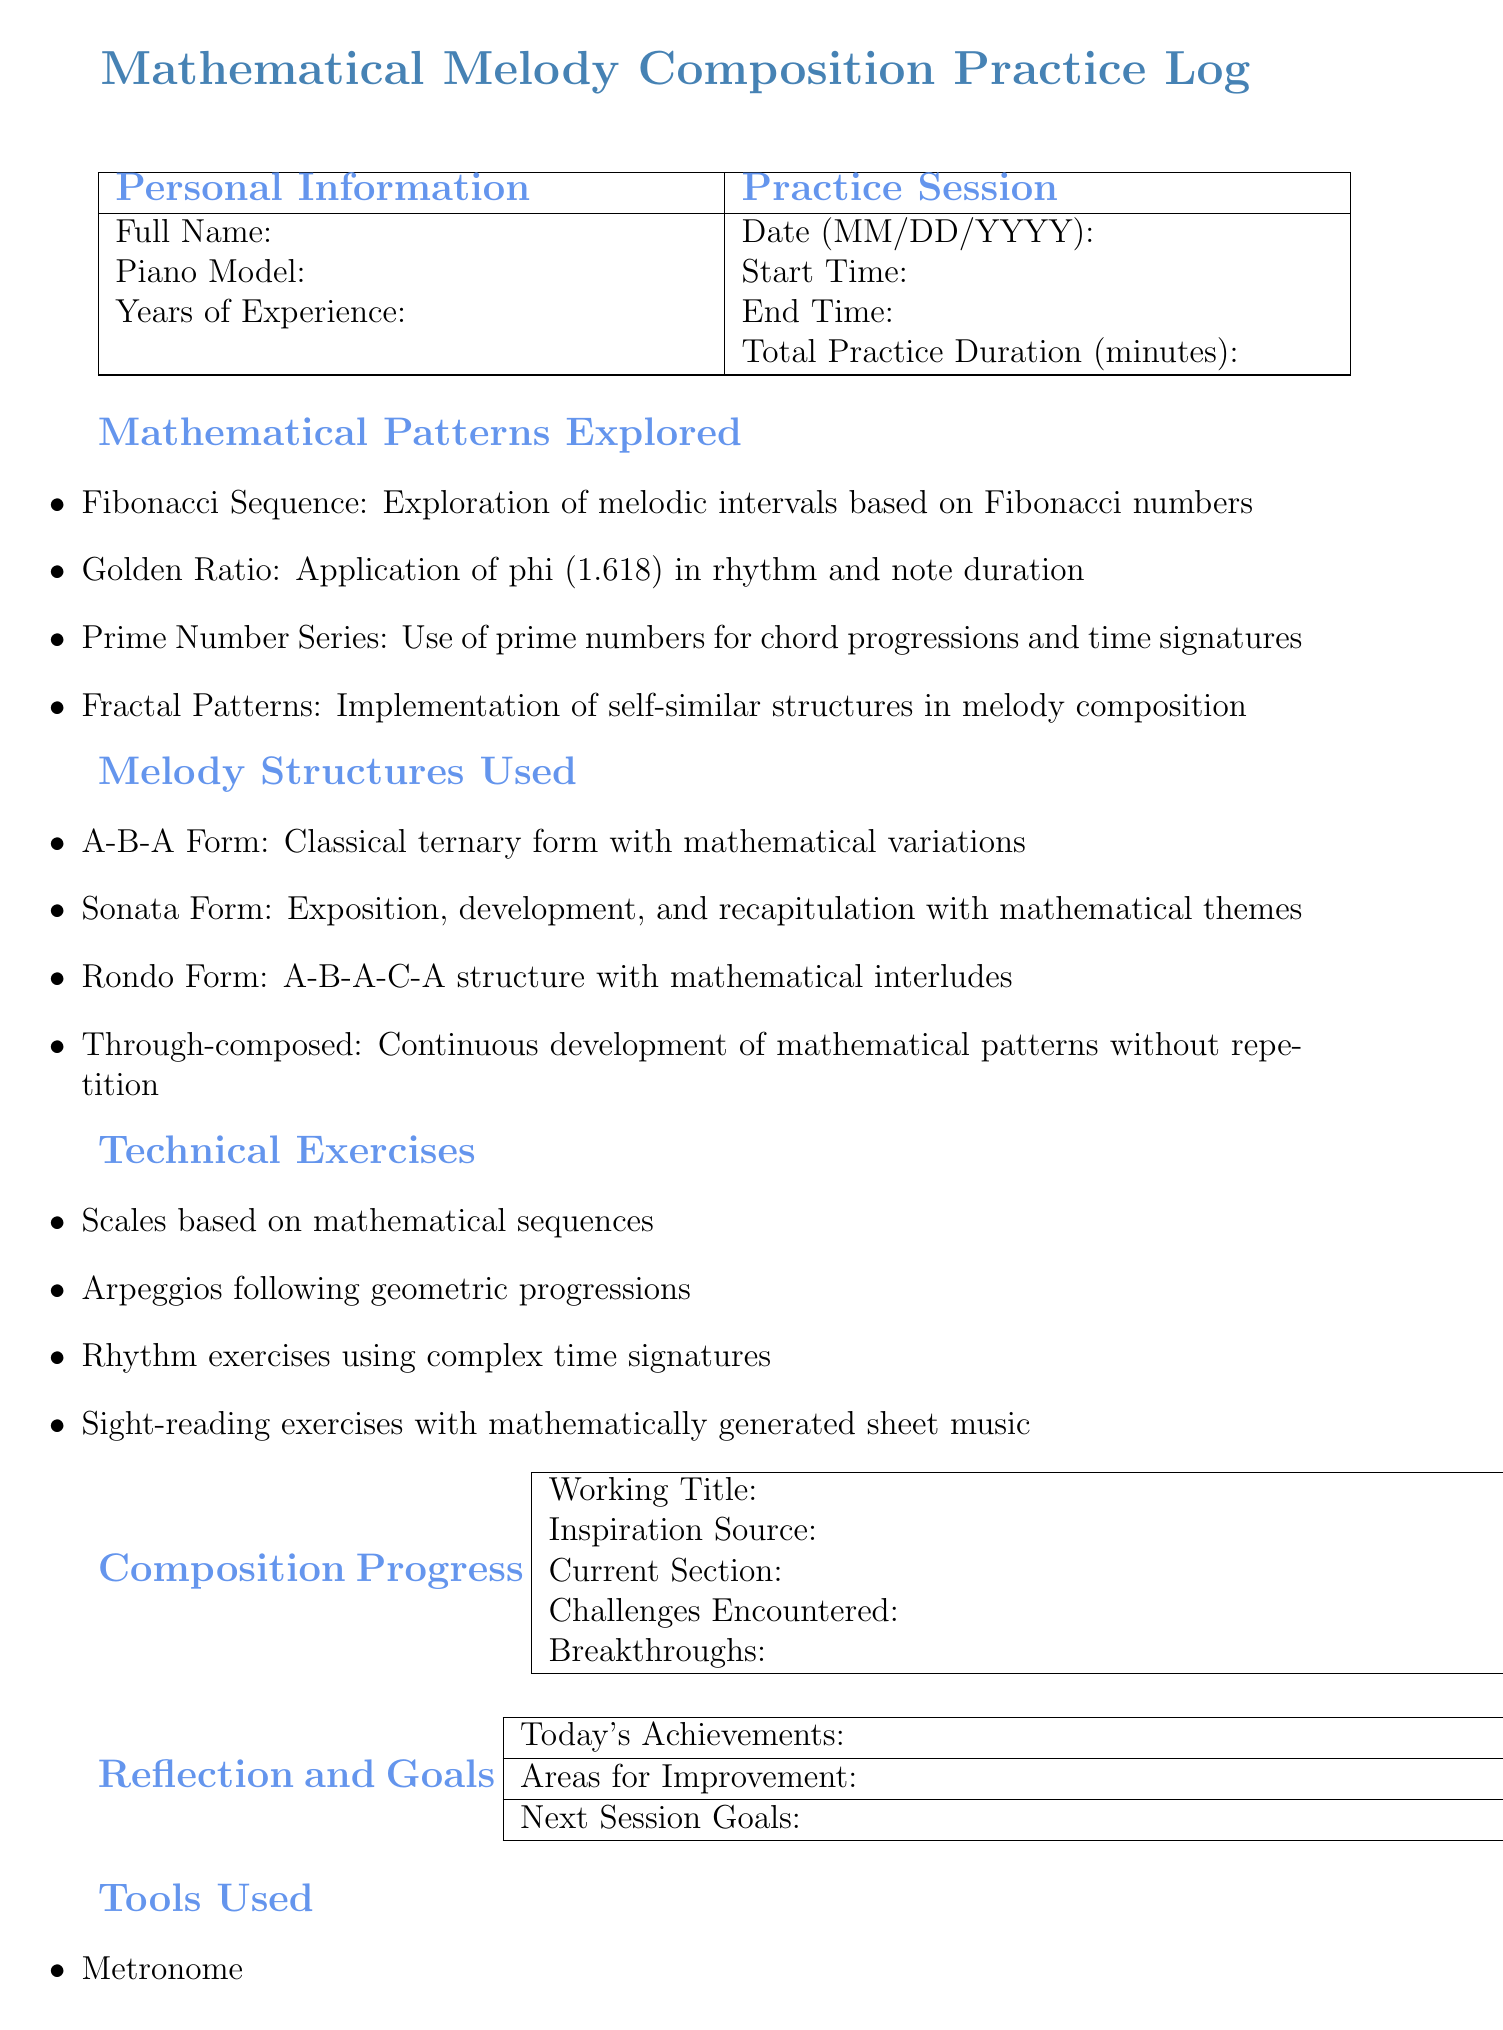What is the title of the document? The title is stated at the top of the document as the main heading.
Answer: Mathematical Melody Composition Practice Log What is the experience level field called? The document includes a section for personal information including a field for experience level.
Answer: Years of Experience What mathematical pattern explores melodic intervals? The document lists various mathematical patterns explored during practice, including one that focuses on melodic intervals.
Answer: Fibonacci Sequence What is the current section of the composition in progress? The composition progress section contains a field to indicate what part of the piece is being worked on.
Answer: Section of the Piece What type of piano is mentioned as an example? The personal information section includes an example of a piano model associated with the practice log.
Answer: Steinway Grand Piano What is indicated under today's achievements? There is a section in the reflection and goals part of the document dedicated to key accomplishments from the practice session.
Answer: Key Accomplishments of the Practice Session What tool is listed for music notation? The document specifies tools used during practice, including one commonly used for music notation.
Answer: Music notation software What structure involves continuous development without repetition? The melody structures section describes a specific structure that is characterized by continuous development.
Answer: Through-composed Who might collaborate with the musician according to the document? The collaborations section includes fields for identifying individuals who may work together with the musician.
Answer: Name of Collaborating Musician 